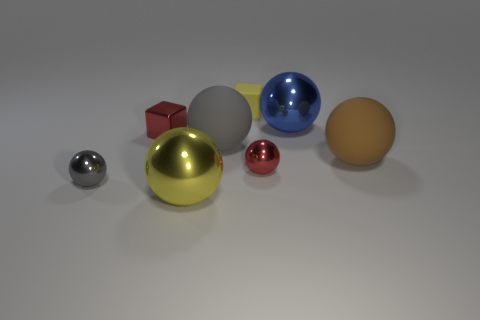Subtract 2 balls. How many balls are left? 4 Subtract all yellow balls. How many balls are left? 5 Subtract all rubber spheres. How many spheres are left? 4 Subtract all brown spheres. Subtract all gray cylinders. How many spheres are left? 5 Add 1 gray spheres. How many objects exist? 9 Subtract all cubes. How many objects are left? 6 Add 1 small yellow blocks. How many small yellow blocks exist? 2 Subtract 0 brown cylinders. How many objects are left? 8 Subtract all tiny red blocks. Subtract all large gray cylinders. How many objects are left? 7 Add 8 small red metallic cubes. How many small red metallic cubes are left? 9 